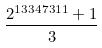Convert formula to latex. <formula><loc_0><loc_0><loc_500><loc_500>\frac { 2 ^ { 1 3 3 4 7 3 1 1 } + 1 } { 3 }</formula> 